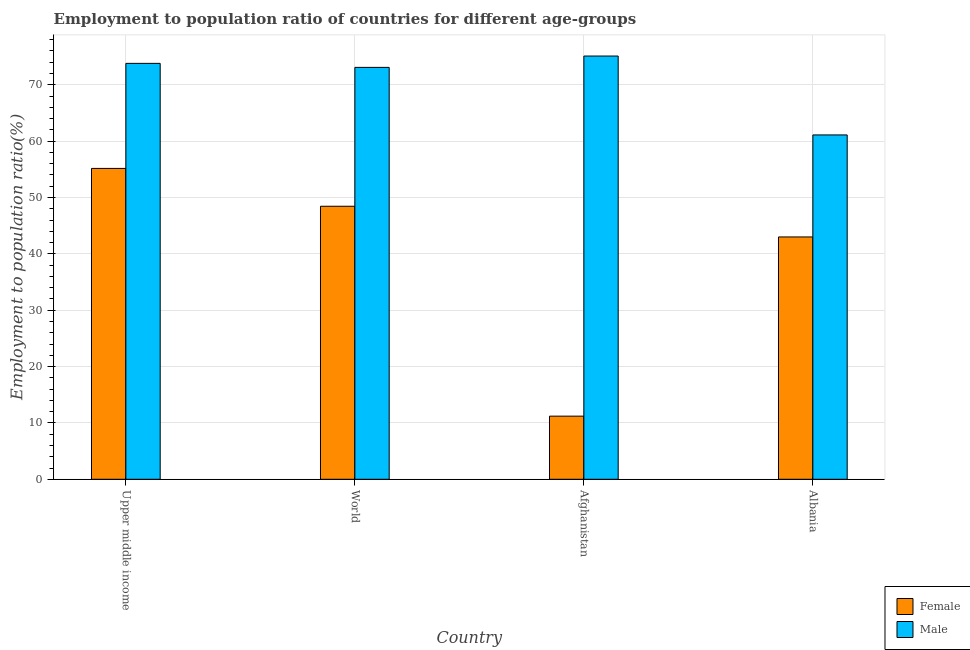How many different coloured bars are there?
Provide a succinct answer. 2. How many groups of bars are there?
Offer a terse response. 4. Are the number of bars per tick equal to the number of legend labels?
Offer a terse response. Yes. How many bars are there on the 3rd tick from the left?
Provide a succinct answer. 2. How many bars are there on the 1st tick from the right?
Provide a short and direct response. 2. What is the label of the 3rd group of bars from the left?
Your answer should be compact. Afghanistan. What is the employment to population ratio(female) in Afghanistan?
Offer a terse response. 11.2. Across all countries, what is the maximum employment to population ratio(female)?
Your answer should be very brief. 55.16. Across all countries, what is the minimum employment to population ratio(female)?
Your answer should be compact. 11.2. In which country was the employment to population ratio(female) maximum?
Your response must be concise. Upper middle income. In which country was the employment to population ratio(male) minimum?
Make the answer very short. Albania. What is the total employment to population ratio(male) in the graph?
Provide a short and direct response. 283.09. What is the difference between the employment to population ratio(female) in Upper middle income and that in World?
Your answer should be compact. 6.72. What is the difference between the employment to population ratio(male) in Afghanistan and the employment to population ratio(female) in World?
Offer a terse response. 26.66. What is the average employment to population ratio(male) per country?
Offer a very short reply. 70.77. What is the difference between the employment to population ratio(male) and employment to population ratio(female) in Albania?
Make the answer very short. 18.1. In how many countries, is the employment to population ratio(male) greater than 64 %?
Offer a very short reply. 3. What is the ratio of the employment to population ratio(female) in Afghanistan to that in Upper middle income?
Provide a succinct answer. 0.2. Is the employment to population ratio(male) in Afghanistan less than that in World?
Make the answer very short. No. What is the difference between the highest and the second highest employment to population ratio(male)?
Offer a very short reply. 1.3. What is the difference between the highest and the lowest employment to population ratio(female)?
Your answer should be very brief. 43.96. In how many countries, is the employment to population ratio(male) greater than the average employment to population ratio(male) taken over all countries?
Give a very brief answer. 3. What does the 2nd bar from the left in Upper middle income represents?
Make the answer very short. Male. What is the difference between two consecutive major ticks on the Y-axis?
Keep it short and to the point. 10. Does the graph contain any zero values?
Provide a succinct answer. No. Does the graph contain grids?
Give a very brief answer. Yes. Where does the legend appear in the graph?
Provide a short and direct response. Bottom right. How are the legend labels stacked?
Your answer should be very brief. Vertical. What is the title of the graph?
Provide a short and direct response. Employment to population ratio of countries for different age-groups. Does "Working capital" appear as one of the legend labels in the graph?
Make the answer very short. No. What is the label or title of the X-axis?
Keep it short and to the point. Country. What is the label or title of the Y-axis?
Make the answer very short. Employment to population ratio(%). What is the Employment to population ratio(%) of Female in Upper middle income?
Provide a succinct answer. 55.16. What is the Employment to population ratio(%) in Male in Upper middle income?
Ensure brevity in your answer.  73.8. What is the Employment to population ratio(%) in Female in World?
Ensure brevity in your answer.  48.44. What is the Employment to population ratio(%) in Male in World?
Ensure brevity in your answer.  73.09. What is the Employment to population ratio(%) in Female in Afghanistan?
Give a very brief answer. 11.2. What is the Employment to population ratio(%) of Male in Afghanistan?
Your answer should be compact. 75.1. What is the Employment to population ratio(%) in Male in Albania?
Offer a very short reply. 61.1. Across all countries, what is the maximum Employment to population ratio(%) of Female?
Your response must be concise. 55.16. Across all countries, what is the maximum Employment to population ratio(%) of Male?
Your answer should be compact. 75.1. Across all countries, what is the minimum Employment to population ratio(%) in Female?
Offer a terse response. 11.2. Across all countries, what is the minimum Employment to population ratio(%) of Male?
Offer a very short reply. 61.1. What is the total Employment to population ratio(%) in Female in the graph?
Your answer should be very brief. 157.8. What is the total Employment to population ratio(%) in Male in the graph?
Provide a succinct answer. 283.09. What is the difference between the Employment to population ratio(%) of Female in Upper middle income and that in World?
Your response must be concise. 6.72. What is the difference between the Employment to population ratio(%) in Male in Upper middle income and that in World?
Provide a succinct answer. 0.71. What is the difference between the Employment to population ratio(%) in Female in Upper middle income and that in Afghanistan?
Offer a very short reply. 43.96. What is the difference between the Employment to population ratio(%) in Male in Upper middle income and that in Afghanistan?
Offer a very short reply. -1.3. What is the difference between the Employment to population ratio(%) in Female in Upper middle income and that in Albania?
Offer a terse response. 12.16. What is the difference between the Employment to population ratio(%) of Male in Upper middle income and that in Albania?
Offer a terse response. 12.7. What is the difference between the Employment to population ratio(%) of Female in World and that in Afghanistan?
Offer a very short reply. 37.24. What is the difference between the Employment to population ratio(%) in Male in World and that in Afghanistan?
Provide a succinct answer. -2.01. What is the difference between the Employment to population ratio(%) in Female in World and that in Albania?
Provide a succinct answer. 5.44. What is the difference between the Employment to population ratio(%) in Male in World and that in Albania?
Your answer should be compact. 11.99. What is the difference between the Employment to population ratio(%) of Female in Afghanistan and that in Albania?
Give a very brief answer. -31.8. What is the difference between the Employment to population ratio(%) of Male in Afghanistan and that in Albania?
Provide a short and direct response. 14. What is the difference between the Employment to population ratio(%) of Female in Upper middle income and the Employment to population ratio(%) of Male in World?
Make the answer very short. -17.93. What is the difference between the Employment to population ratio(%) in Female in Upper middle income and the Employment to population ratio(%) in Male in Afghanistan?
Your response must be concise. -19.94. What is the difference between the Employment to population ratio(%) of Female in Upper middle income and the Employment to population ratio(%) of Male in Albania?
Ensure brevity in your answer.  -5.94. What is the difference between the Employment to population ratio(%) in Female in World and the Employment to population ratio(%) in Male in Afghanistan?
Offer a very short reply. -26.66. What is the difference between the Employment to population ratio(%) of Female in World and the Employment to population ratio(%) of Male in Albania?
Your answer should be compact. -12.66. What is the difference between the Employment to population ratio(%) in Female in Afghanistan and the Employment to population ratio(%) in Male in Albania?
Make the answer very short. -49.9. What is the average Employment to population ratio(%) in Female per country?
Ensure brevity in your answer.  39.45. What is the average Employment to population ratio(%) of Male per country?
Make the answer very short. 70.77. What is the difference between the Employment to population ratio(%) in Female and Employment to population ratio(%) in Male in Upper middle income?
Offer a very short reply. -18.64. What is the difference between the Employment to population ratio(%) of Female and Employment to population ratio(%) of Male in World?
Your answer should be compact. -24.64. What is the difference between the Employment to population ratio(%) in Female and Employment to population ratio(%) in Male in Afghanistan?
Your response must be concise. -63.9. What is the difference between the Employment to population ratio(%) of Female and Employment to population ratio(%) of Male in Albania?
Your answer should be compact. -18.1. What is the ratio of the Employment to population ratio(%) in Female in Upper middle income to that in World?
Give a very brief answer. 1.14. What is the ratio of the Employment to population ratio(%) of Male in Upper middle income to that in World?
Give a very brief answer. 1.01. What is the ratio of the Employment to population ratio(%) in Female in Upper middle income to that in Afghanistan?
Offer a terse response. 4.92. What is the ratio of the Employment to population ratio(%) of Male in Upper middle income to that in Afghanistan?
Offer a terse response. 0.98. What is the ratio of the Employment to population ratio(%) in Female in Upper middle income to that in Albania?
Your answer should be very brief. 1.28. What is the ratio of the Employment to population ratio(%) in Male in Upper middle income to that in Albania?
Make the answer very short. 1.21. What is the ratio of the Employment to population ratio(%) of Female in World to that in Afghanistan?
Keep it short and to the point. 4.33. What is the ratio of the Employment to population ratio(%) in Male in World to that in Afghanistan?
Your response must be concise. 0.97. What is the ratio of the Employment to population ratio(%) in Female in World to that in Albania?
Your response must be concise. 1.13. What is the ratio of the Employment to population ratio(%) of Male in World to that in Albania?
Ensure brevity in your answer.  1.2. What is the ratio of the Employment to population ratio(%) of Female in Afghanistan to that in Albania?
Offer a very short reply. 0.26. What is the ratio of the Employment to population ratio(%) in Male in Afghanistan to that in Albania?
Your response must be concise. 1.23. What is the difference between the highest and the second highest Employment to population ratio(%) of Female?
Your answer should be very brief. 6.72. What is the difference between the highest and the second highest Employment to population ratio(%) of Male?
Provide a succinct answer. 1.3. What is the difference between the highest and the lowest Employment to population ratio(%) of Female?
Keep it short and to the point. 43.96. 